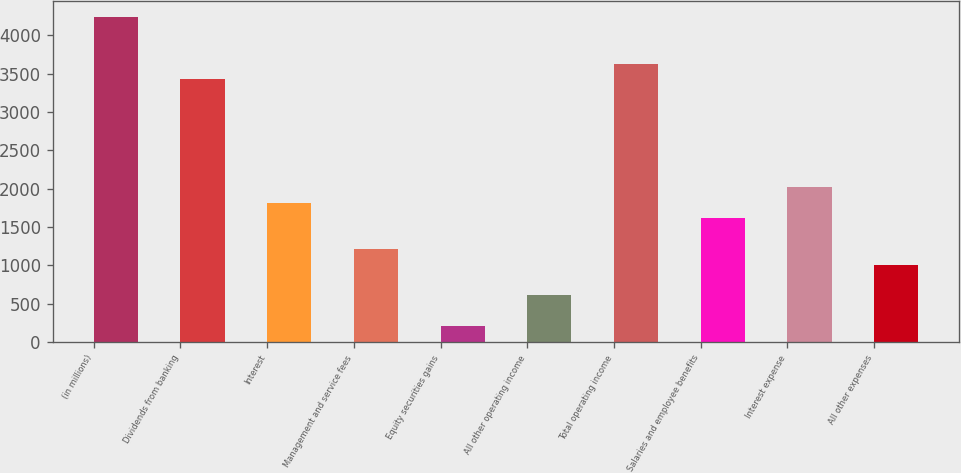Convert chart to OTSL. <chart><loc_0><loc_0><loc_500><loc_500><bar_chart><fcel>(in millions)<fcel>Dividends from banking<fcel>Interest<fcel>Management and service fees<fcel>Equity securities gains<fcel>All other operating income<fcel>Total operating income<fcel>Salaries and employee benefits<fcel>Interest expense<fcel>All other expenses<nl><fcel>4231.4<fcel>3425.8<fcel>1814.6<fcel>1210.4<fcel>203.4<fcel>606.2<fcel>3627.2<fcel>1613.2<fcel>2016<fcel>1009<nl></chart> 